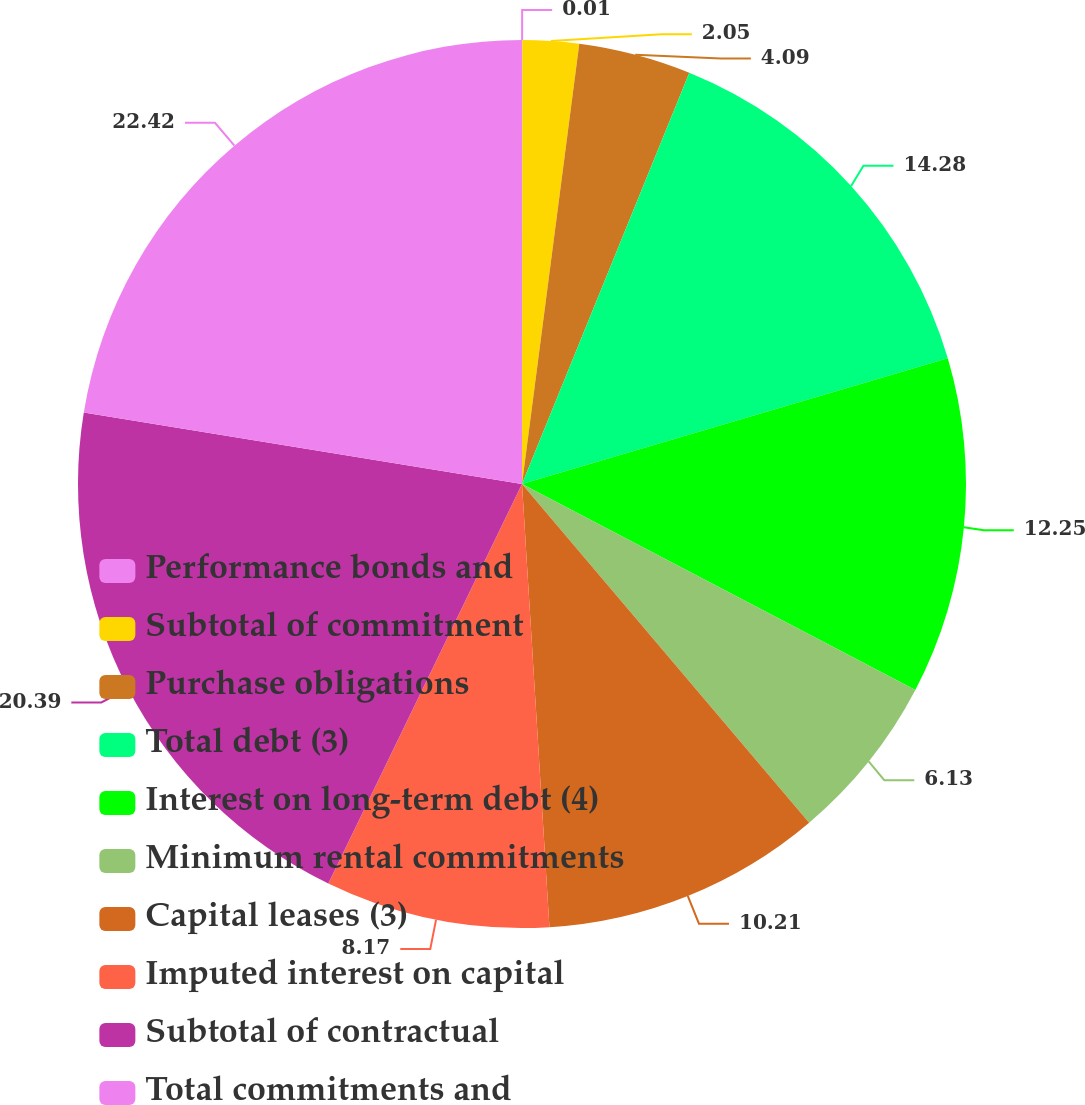Convert chart. <chart><loc_0><loc_0><loc_500><loc_500><pie_chart><fcel>Performance bonds and<fcel>Subtotal of commitment<fcel>Purchase obligations<fcel>Total debt (3)<fcel>Interest on long-term debt (4)<fcel>Minimum rental commitments<fcel>Capital leases (3)<fcel>Imputed interest on capital<fcel>Subtotal of contractual<fcel>Total commitments and<nl><fcel>0.01%<fcel>2.05%<fcel>4.09%<fcel>14.28%<fcel>12.25%<fcel>6.13%<fcel>10.21%<fcel>8.17%<fcel>20.39%<fcel>22.43%<nl></chart> 